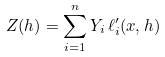Convert formula to latex. <formula><loc_0><loc_0><loc_500><loc_500>Z ( h ) = \sum _ { i = 1 } ^ { n } Y _ { i } \, \ell _ { i } ^ { \prime } ( x , h )</formula> 